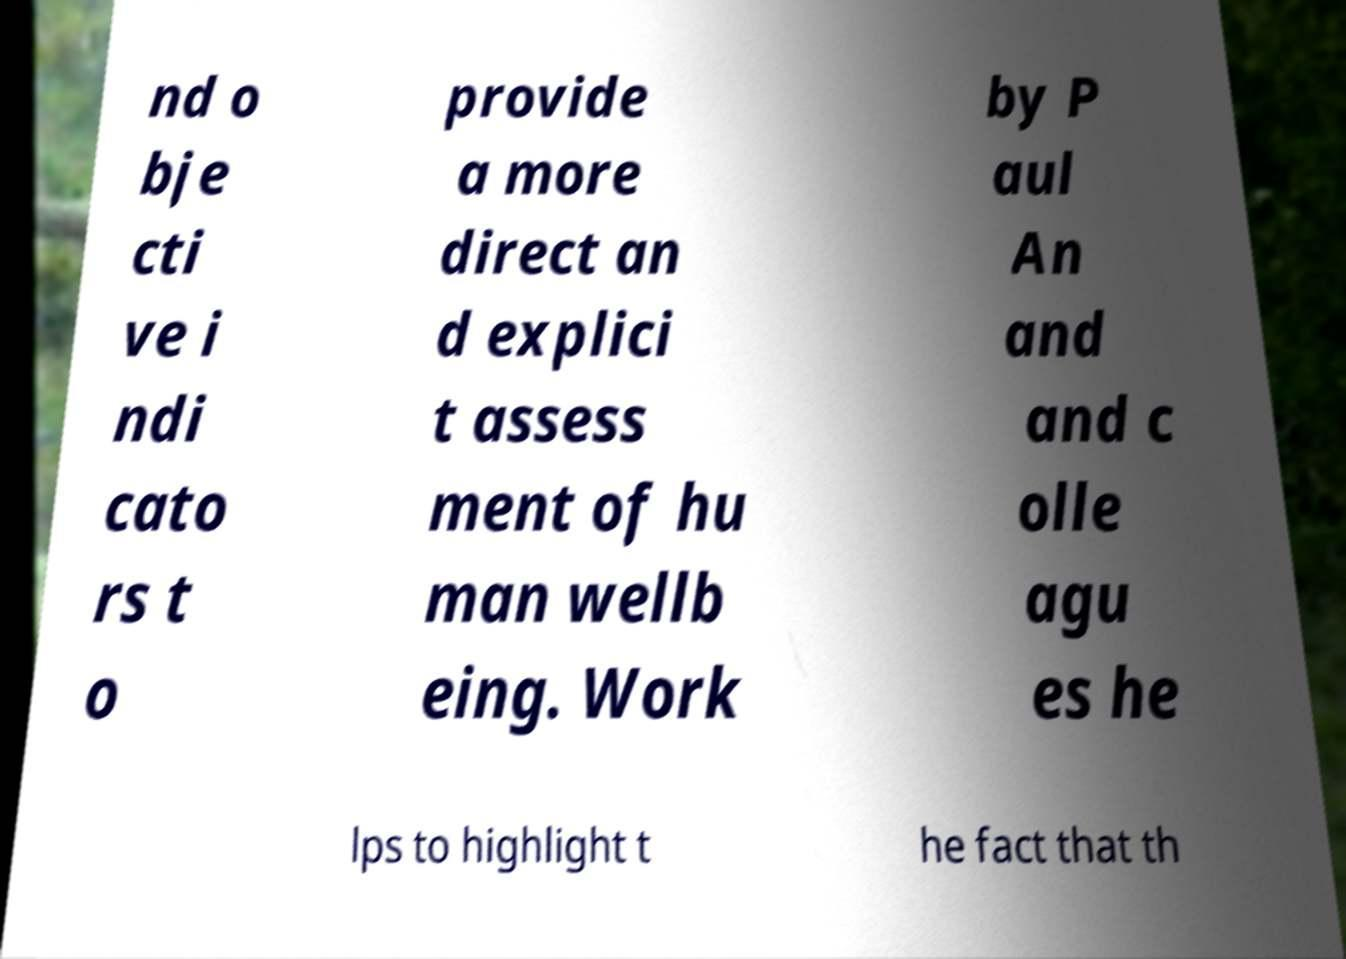Please read and relay the text visible in this image. What does it say? nd o bje cti ve i ndi cato rs t o provide a more direct an d explici t assess ment of hu man wellb eing. Work by P aul An and and c olle agu es he lps to highlight t he fact that th 